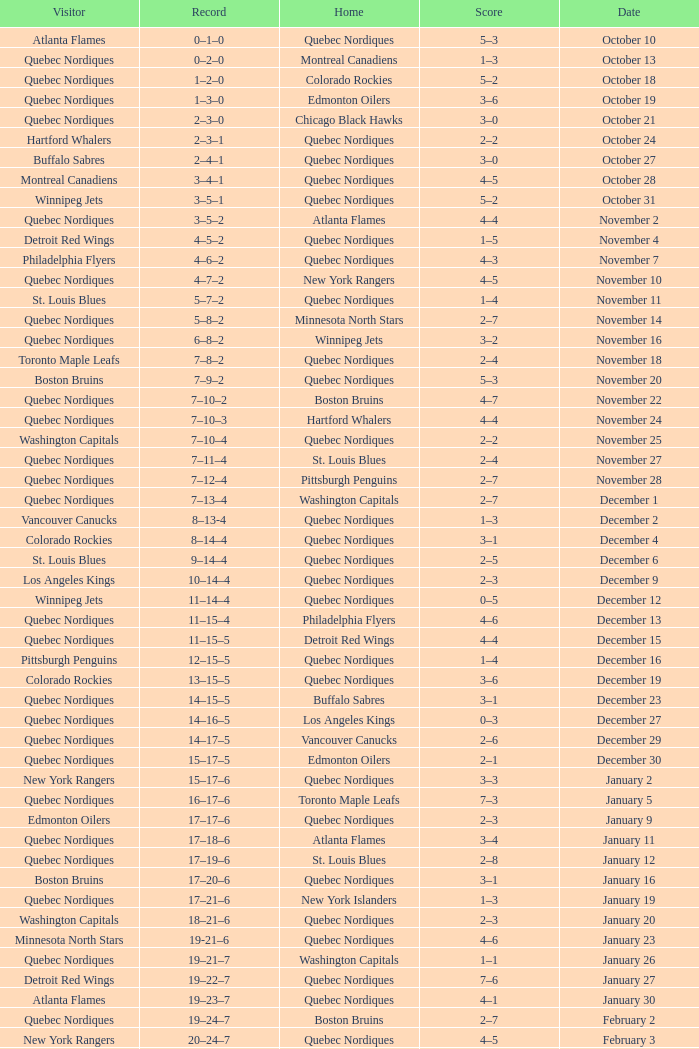Which Home has a Record of 11–14–4? Quebec Nordiques. Could you parse the entire table as a dict? {'header': ['Visitor', 'Record', 'Home', 'Score', 'Date'], 'rows': [['Atlanta Flames', '0–1–0', 'Quebec Nordiques', '5–3', 'October 10'], ['Quebec Nordiques', '0–2–0', 'Montreal Canadiens', '1–3', 'October 13'], ['Quebec Nordiques', '1–2–0', 'Colorado Rockies', '5–2', 'October 18'], ['Quebec Nordiques', '1–3–0', 'Edmonton Oilers', '3–6', 'October 19'], ['Quebec Nordiques', '2–3–0', 'Chicago Black Hawks', '3–0', 'October 21'], ['Hartford Whalers', '2–3–1', 'Quebec Nordiques', '2–2', 'October 24'], ['Buffalo Sabres', '2–4–1', 'Quebec Nordiques', '3–0', 'October 27'], ['Montreal Canadiens', '3–4–1', 'Quebec Nordiques', '4–5', 'October 28'], ['Winnipeg Jets', '3–5–1', 'Quebec Nordiques', '5–2', 'October 31'], ['Quebec Nordiques', '3–5–2', 'Atlanta Flames', '4–4', 'November 2'], ['Detroit Red Wings', '4–5–2', 'Quebec Nordiques', '1–5', 'November 4'], ['Philadelphia Flyers', '4–6–2', 'Quebec Nordiques', '4–3', 'November 7'], ['Quebec Nordiques', '4–7–2', 'New York Rangers', '4–5', 'November 10'], ['St. Louis Blues', '5–7–2', 'Quebec Nordiques', '1–4', 'November 11'], ['Quebec Nordiques', '5–8–2', 'Minnesota North Stars', '2–7', 'November 14'], ['Quebec Nordiques', '6–8–2', 'Winnipeg Jets', '3–2', 'November 16'], ['Toronto Maple Leafs', '7–8–2', 'Quebec Nordiques', '2–4', 'November 18'], ['Boston Bruins', '7–9–2', 'Quebec Nordiques', '5–3', 'November 20'], ['Quebec Nordiques', '7–10–2', 'Boston Bruins', '4–7', 'November 22'], ['Quebec Nordiques', '7–10–3', 'Hartford Whalers', '4–4', 'November 24'], ['Washington Capitals', '7–10–4', 'Quebec Nordiques', '2–2', 'November 25'], ['Quebec Nordiques', '7–11–4', 'St. Louis Blues', '2–4', 'November 27'], ['Quebec Nordiques', '7–12–4', 'Pittsburgh Penguins', '2–7', 'November 28'], ['Quebec Nordiques', '7–13–4', 'Washington Capitals', '2–7', 'December 1'], ['Vancouver Canucks', '8–13-4', 'Quebec Nordiques', '1–3', 'December 2'], ['Colorado Rockies', '8–14–4', 'Quebec Nordiques', '3–1', 'December 4'], ['St. Louis Blues', '9–14–4', 'Quebec Nordiques', '2–5', 'December 6'], ['Los Angeles Kings', '10–14–4', 'Quebec Nordiques', '2–3', 'December 9'], ['Winnipeg Jets', '11–14–4', 'Quebec Nordiques', '0–5', 'December 12'], ['Quebec Nordiques', '11–15–4', 'Philadelphia Flyers', '4–6', 'December 13'], ['Quebec Nordiques', '11–15–5', 'Detroit Red Wings', '4–4', 'December 15'], ['Pittsburgh Penguins', '12–15–5', 'Quebec Nordiques', '1–4', 'December 16'], ['Colorado Rockies', '13–15–5', 'Quebec Nordiques', '3–6', 'December 19'], ['Quebec Nordiques', '14–15–5', 'Buffalo Sabres', '3–1', 'December 23'], ['Quebec Nordiques', '14–16–5', 'Los Angeles Kings', '0–3', 'December 27'], ['Quebec Nordiques', '14–17–5', 'Vancouver Canucks', '2–6', 'December 29'], ['Quebec Nordiques', '15–17–5', 'Edmonton Oilers', '2–1', 'December 30'], ['New York Rangers', '15–17–6', 'Quebec Nordiques', '3–3', 'January 2'], ['Quebec Nordiques', '16–17–6', 'Toronto Maple Leafs', '7–3', 'January 5'], ['Edmonton Oilers', '17–17–6', 'Quebec Nordiques', '2–3', 'January 9'], ['Quebec Nordiques', '17–18–6', 'Atlanta Flames', '3–4', 'January 11'], ['Quebec Nordiques', '17–19–6', 'St. Louis Blues', '2–8', 'January 12'], ['Boston Bruins', '17–20–6', 'Quebec Nordiques', '3–1', 'January 16'], ['Quebec Nordiques', '17–21–6', 'New York Islanders', '1–3', 'January 19'], ['Washington Capitals', '18–21–6', 'Quebec Nordiques', '2–3', 'January 20'], ['Minnesota North Stars', '19-21–6', 'Quebec Nordiques', '4–6', 'January 23'], ['Quebec Nordiques', '19–21–7', 'Washington Capitals', '1–1', 'January 26'], ['Detroit Red Wings', '19–22–7', 'Quebec Nordiques', '7–6', 'January 27'], ['Atlanta Flames', '19–23–7', 'Quebec Nordiques', '4–1', 'January 30'], ['Quebec Nordiques', '19–24–7', 'Boston Bruins', '2–7', 'February 2'], ['New York Rangers', '20–24–7', 'Quebec Nordiques', '4–5', 'February 3'], ['Chicago Black Hawks', '20–24–8', 'Quebec Nordiques', '3–3', 'February 6'], ['Quebec Nordiques', '20–25–8', 'New York Islanders', '0–5', 'February 9'], ['Quebec Nordiques', '20–26–8', 'New York Rangers', '1–3', 'February 10'], ['Quebec Nordiques', '20–27–8', 'Montreal Canadiens', '1–5', 'February 14'], ['Quebec Nordiques', '20–28–8', 'Winnipeg Jets', '5–6', 'February 17'], ['Quebec Nordiques', '20–29–8', 'Minnesota North Stars', '2–6', 'February 18'], ['Buffalo Sabres', '20–30–8', 'Quebec Nordiques', '3–1', 'February 19'], ['Quebec Nordiques', '20–31–8', 'Pittsburgh Penguins', '1–2', 'February 23'], ['Pittsburgh Penguins', '21–31–8', 'Quebec Nordiques', '0–2', 'February 24'], ['Hartford Whalers', '22–31–8', 'Quebec Nordiques', '5–9', 'February 26'], ['New York Islanders', '22–32–8', 'Quebec Nordiques', '5–3', 'February 27'], ['Los Angeles Kings', '22–33–8', 'Quebec Nordiques', '4–3', 'March 2'], ['Minnesota North Stars', '22–33–9', 'Quebec Nordiques', '3-3', 'March 5'], ['Quebec Nordiques', '22–34–9', 'Toronto Maple Leafs', '2–3', 'March 8'], ['Toronto Maple Leafs', '23–34-9', 'Quebec Nordiques', '4–5', 'March 9'], ['Edmonton Oilers', '23–35–9', 'Quebec Nordiques', '6–3', 'March 12'], ['Vancouver Canucks', '23–36–9', 'Quebec Nordiques', '3–2', 'March 16'], ['Quebec Nordiques', '23–37–9', 'Chicago Black Hawks', '2–5', 'March 19'], ['Quebec Nordiques', '24–37–9', 'Colorado Rockies', '6–2', 'March 20'], ['Quebec Nordiques', '24–38-9', 'Los Angeles Kings', '1-4', 'March 22'], ['Quebec Nordiques', '25–38–9', 'Vancouver Canucks', '6–2', 'March 23'], ['Chicago Black Hawks', '25–39–9', 'Quebec Nordiques', '7–2', 'March 26'], ['Quebec Nordiques', '25–40–9', 'Philadelphia Flyers', '2–5', 'March 27'], ['Quebec Nordiques', '25–41–9', 'Detroit Red Wings', '7–9', 'March 29'], ['New York Islanders', '25–42–9', 'Quebec Nordiques', '9–6', 'March 30'], ['Philadelphia Flyers', '25–42–10', 'Quebec Nordiques', '3–3', 'April 1'], ['Quebec Nordiques', '25–43–10', 'Buffalo Sabres', '3–8', 'April 3'], ['Quebec Nordiques', '25–44–10', 'Hartford Whalers', '2–9', 'April 4'], ['Montreal Canadiens', '25–44–11', 'Quebec Nordiques', '4–4', 'April 6']]} 